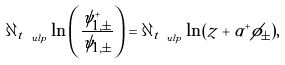Convert formula to latex. <formula><loc_0><loc_0><loc_500><loc_500>\partial _ { t _ { \ u l p } } \ln \left ( \frac { \psi _ { 1 , \pm } ^ { + } } { \psi _ { 1 , \pm } } \right ) = \partial _ { t _ { \ u l p } } \ln ( z + \alpha ^ { + } \phi _ { \pm } ) ,</formula> 